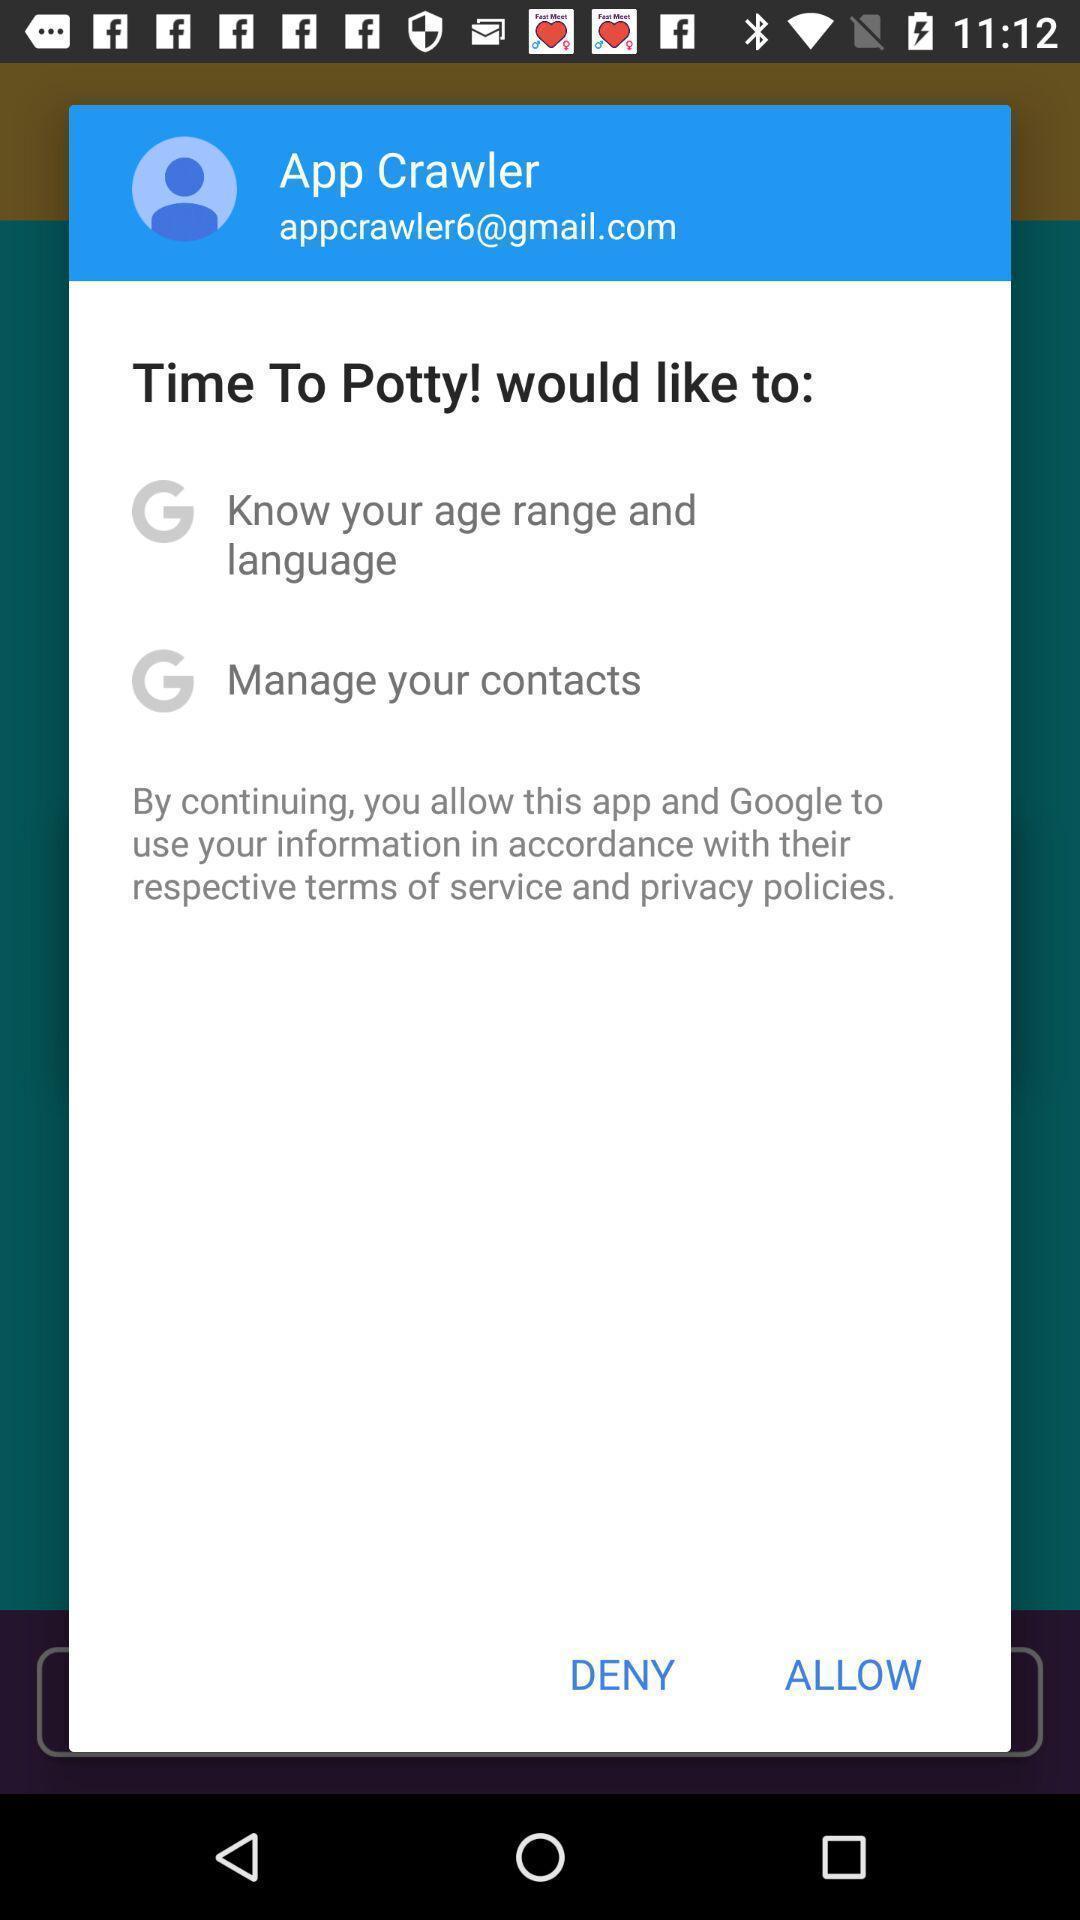Provide a textual representation of this image. Popup page for allowance of terms and polices. 